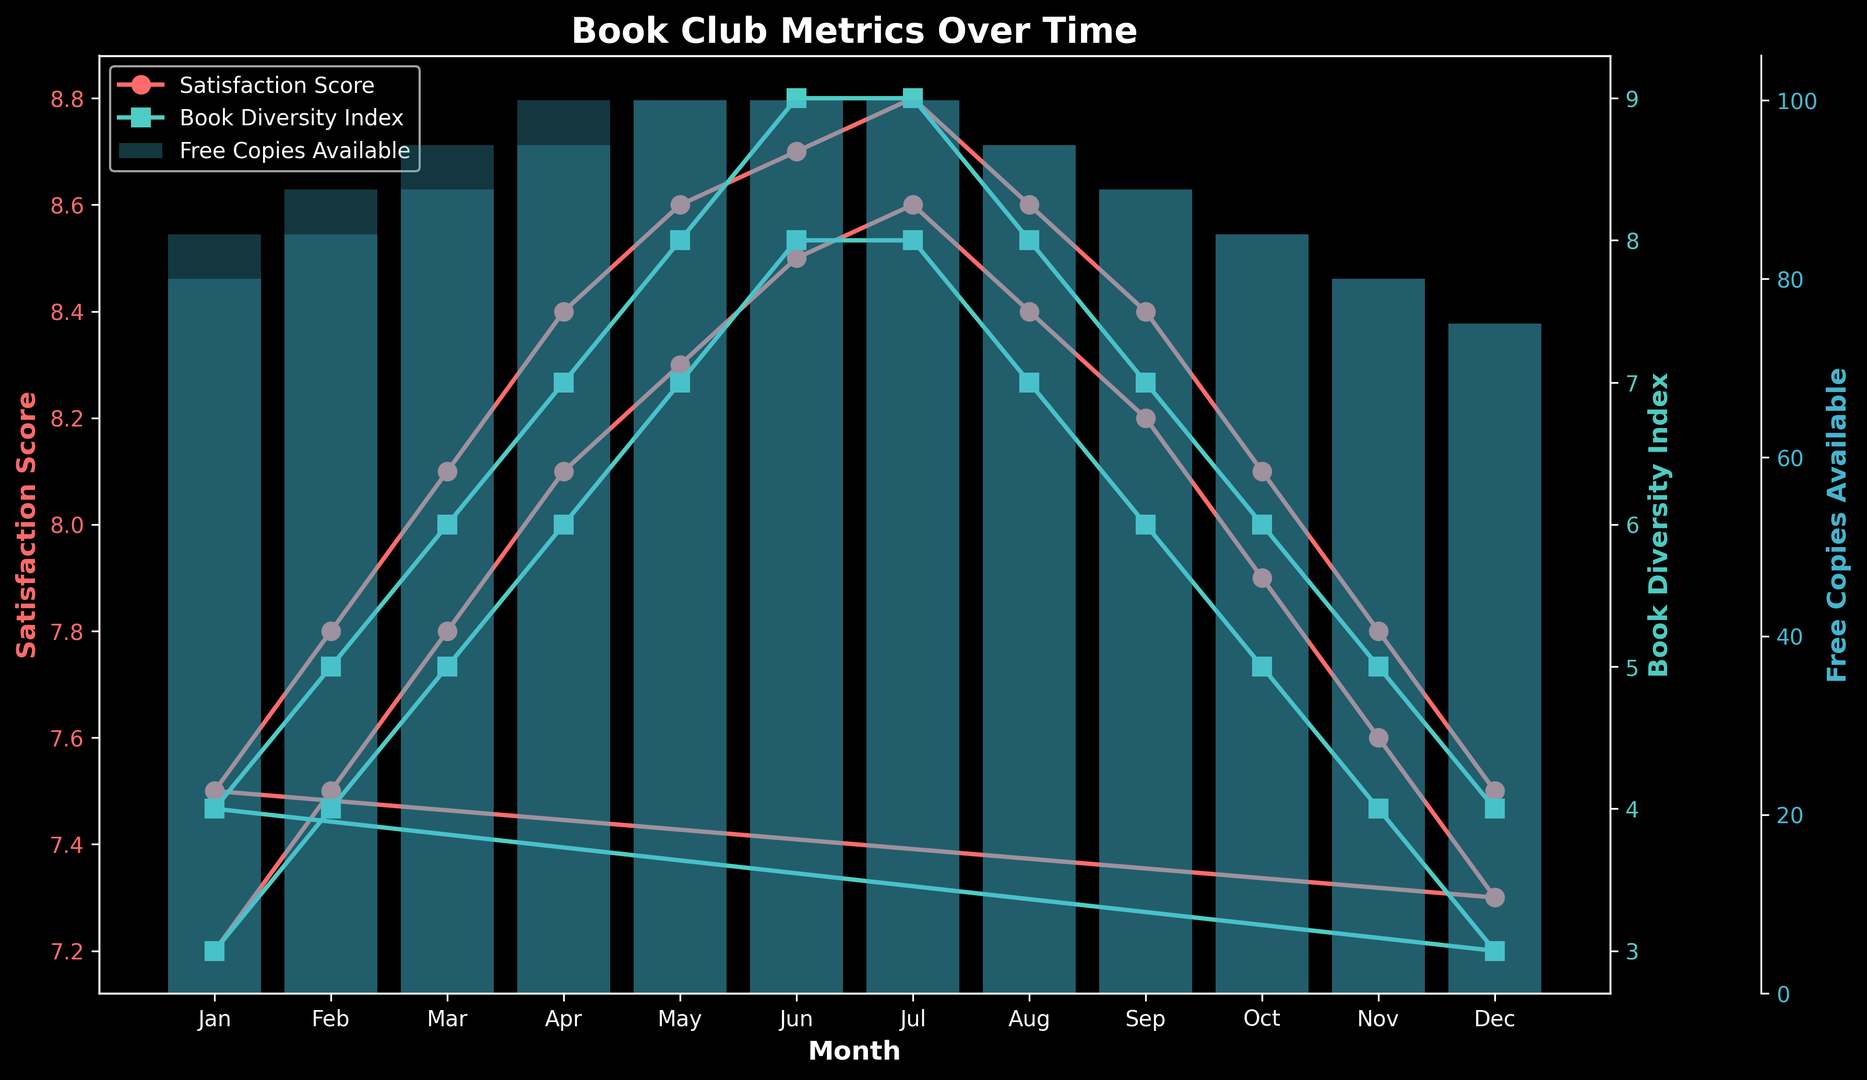What's the trend in Satisfaction Scores over the months? The Satisfaction Scores generally show an upward trend from January to July, peak in July, and then show a downward trend from August to December.
Answer: Upward then downward How many months have Free Copies Available equal to 100? By inspecting the bar heights for Free Copies Available, we see that they reach the topmost value of 100 in 10 months.
Answer: 10 Compare the Satisfaction Scores in July and December. Which month has a higher score? In July, the Satisfaction Score is 8.8, while in December, it is 7.5. Therefore, July has a higher score.
Answer: July During which months do both the Book Diversity Index and Free Copies Available show a decreasing trend? Both indices decrease in August, September, October, November, and December.
Answer: August to December What is the relationship between the Satisfaction Score and Book Diversity Index in the first 6 months? In the first 6 months (January to June), both the Satisfaction Score and the Book Diversity Index increase.
Answer: Both increase Calculate the average Book Diversity Index in the first and last six months. Which is higher? The first six months' indexes are (3, 4, 5, 6, 7, 8) with an average of 5.5. The last six months' indexes are (7, 6, 5, 4, 3, 4) with an average of 4.83. The average is higher in the first six months.
Answer: First six months What month had the highest Satisfaction Score and what was the value? By locating the peak in the Satisfaction Score line, we see that July had the highest Satisfaction Score of 8.8.
Answer: July, 8.8 Is there a visible correlation between the Satisfaction Score and Free Copies Available? As the Free Copies Available increase to 100, the Satisfaction Scores tend to be higher. Conversely, lower numbers of Free Copies Available also see lower Satisfaction Scores.
Answer: Positive correlation What is the difference in Free Copies Available between March and November? In March, 95 copies are available, while in November, 80 are available. The difference is 95 - 80 = 15.
Answer: 15 Compare the average Satisfaction Score for the first half of the year (January to June) versus the second half (July to December). Which period is higher? First half scores = (7.2, 7.5, 7.8, 8.1, 8.3, 8.5) averaging to (7.5667); second half = (8.6, 8.4, 8.2, 7.9, 7.6, 7.3) averaging to (8.0), so the second half is higher.
Answer: Second half 